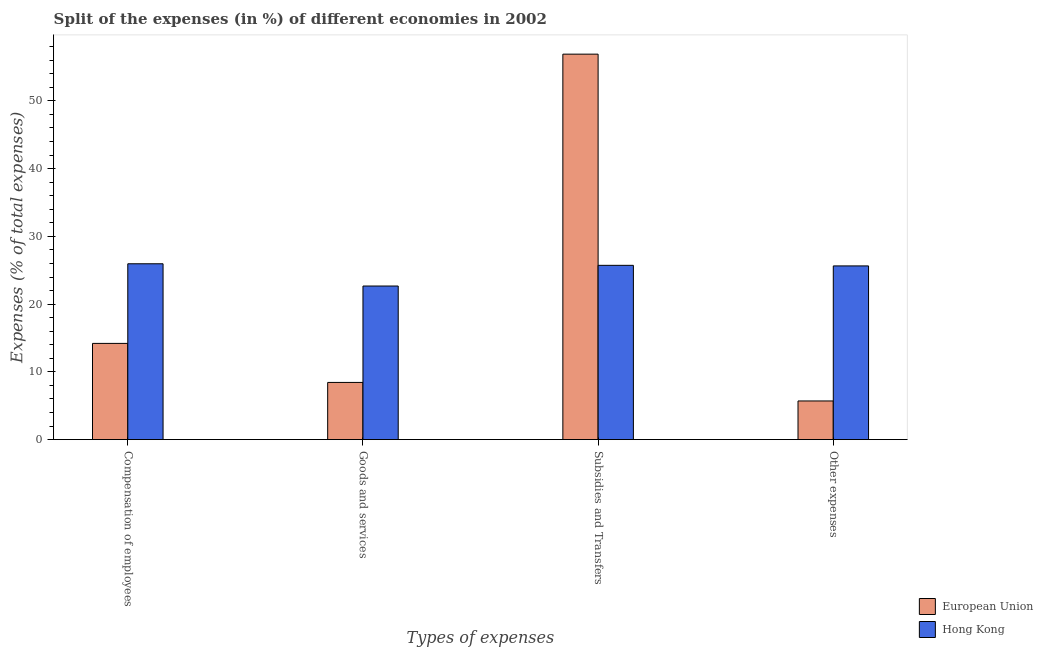Are the number of bars per tick equal to the number of legend labels?
Your response must be concise. Yes. Are the number of bars on each tick of the X-axis equal?
Ensure brevity in your answer.  Yes. How many bars are there on the 1st tick from the left?
Give a very brief answer. 2. How many bars are there on the 3rd tick from the right?
Offer a very short reply. 2. What is the label of the 1st group of bars from the left?
Provide a succinct answer. Compensation of employees. What is the percentage of amount spent on subsidies in Hong Kong?
Give a very brief answer. 25.72. Across all countries, what is the maximum percentage of amount spent on compensation of employees?
Your response must be concise. 25.95. Across all countries, what is the minimum percentage of amount spent on subsidies?
Ensure brevity in your answer.  25.72. In which country was the percentage of amount spent on subsidies maximum?
Offer a terse response. European Union. In which country was the percentage of amount spent on other expenses minimum?
Make the answer very short. European Union. What is the total percentage of amount spent on subsidies in the graph?
Give a very brief answer. 82.62. What is the difference between the percentage of amount spent on subsidies in European Union and that in Hong Kong?
Make the answer very short. 31.17. What is the difference between the percentage of amount spent on goods and services in European Union and the percentage of amount spent on subsidies in Hong Kong?
Your answer should be compact. -17.28. What is the average percentage of amount spent on subsidies per country?
Give a very brief answer. 41.31. What is the difference between the percentage of amount spent on other expenses and percentage of amount spent on compensation of employees in European Union?
Ensure brevity in your answer.  -8.5. In how many countries, is the percentage of amount spent on subsidies greater than 16 %?
Your answer should be very brief. 2. What is the ratio of the percentage of amount spent on goods and services in European Union to that in Hong Kong?
Your answer should be very brief. 0.37. Is the percentage of amount spent on compensation of employees in European Union less than that in Hong Kong?
Provide a succinct answer. Yes. Is the difference between the percentage of amount spent on compensation of employees in European Union and Hong Kong greater than the difference between the percentage of amount spent on other expenses in European Union and Hong Kong?
Ensure brevity in your answer.  Yes. What is the difference between the highest and the second highest percentage of amount spent on subsidies?
Your response must be concise. 31.17. What is the difference between the highest and the lowest percentage of amount spent on subsidies?
Make the answer very short. 31.17. Is it the case that in every country, the sum of the percentage of amount spent on goods and services and percentage of amount spent on compensation of employees is greater than the sum of percentage of amount spent on other expenses and percentage of amount spent on subsidies?
Offer a very short reply. No. What does the 2nd bar from the left in Subsidies and Transfers represents?
Offer a terse response. Hong Kong. Are the values on the major ticks of Y-axis written in scientific E-notation?
Keep it short and to the point. No. Where does the legend appear in the graph?
Your answer should be very brief. Bottom right. What is the title of the graph?
Give a very brief answer. Split of the expenses (in %) of different economies in 2002. What is the label or title of the X-axis?
Ensure brevity in your answer.  Types of expenses. What is the label or title of the Y-axis?
Ensure brevity in your answer.  Expenses (% of total expenses). What is the Expenses (% of total expenses) of European Union in Compensation of employees?
Your answer should be compact. 14.2. What is the Expenses (% of total expenses) of Hong Kong in Compensation of employees?
Your answer should be very brief. 25.95. What is the Expenses (% of total expenses) of European Union in Goods and services?
Keep it short and to the point. 8.44. What is the Expenses (% of total expenses) in Hong Kong in Goods and services?
Offer a very short reply. 22.67. What is the Expenses (% of total expenses) of European Union in Subsidies and Transfers?
Give a very brief answer. 56.89. What is the Expenses (% of total expenses) of Hong Kong in Subsidies and Transfers?
Your answer should be very brief. 25.72. What is the Expenses (% of total expenses) in European Union in Other expenses?
Your response must be concise. 5.7. What is the Expenses (% of total expenses) of Hong Kong in Other expenses?
Offer a terse response. 25.64. Across all Types of expenses, what is the maximum Expenses (% of total expenses) in European Union?
Your response must be concise. 56.89. Across all Types of expenses, what is the maximum Expenses (% of total expenses) of Hong Kong?
Your answer should be very brief. 25.95. Across all Types of expenses, what is the minimum Expenses (% of total expenses) in European Union?
Make the answer very short. 5.7. Across all Types of expenses, what is the minimum Expenses (% of total expenses) in Hong Kong?
Offer a terse response. 22.67. What is the total Expenses (% of total expenses) of European Union in the graph?
Provide a succinct answer. 85.24. What is the total Expenses (% of total expenses) in Hong Kong in the graph?
Give a very brief answer. 99.98. What is the difference between the Expenses (% of total expenses) of European Union in Compensation of employees and that in Goods and services?
Your response must be concise. 5.76. What is the difference between the Expenses (% of total expenses) in Hong Kong in Compensation of employees and that in Goods and services?
Make the answer very short. 3.29. What is the difference between the Expenses (% of total expenses) in European Union in Compensation of employees and that in Subsidies and Transfers?
Your answer should be very brief. -42.69. What is the difference between the Expenses (% of total expenses) in Hong Kong in Compensation of employees and that in Subsidies and Transfers?
Keep it short and to the point. 0.23. What is the difference between the Expenses (% of total expenses) in European Union in Compensation of employees and that in Other expenses?
Your response must be concise. 8.5. What is the difference between the Expenses (% of total expenses) in Hong Kong in Compensation of employees and that in Other expenses?
Keep it short and to the point. 0.32. What is the difference between the Expenses (% of total expenses) of European Union in Goods and services and that in Subsidies and Transfers?
Give a very brief answer. -48.46. What is the difference between the Expenses (% of total expenses) in Hong Kong in Goods and services and that in Subsidies and Transfers?
Ensure brevity in your answer.  -3.06. What is the difference between the Expenses (% of total expenses) of European Union in Goods and services and that in Other expenses?
Offer a very short reply. 2.73. What is the difference between the Expenses (% of total expenses) of Hong Kong in Goods and services and that in Other expenses?
Make the answer very short. -2.97. What is the difference between the Expenses (% of total expenses) of European Union in Subsidies and Transfers and that in Other expenses?
Give a very brief answer. 51.19. What is the difference between the Expenses (% of total expenses) in Hong Kong in Subsidies and Transfers and that in Other expenses?
Make the answer very short. 0.09. What is the difference between the Expenses (% of total expenses) in European Union in Compensation of employees and the Expenses (% of total expenses) in Hong Kong in Goods and services?
Your answer should be very brief. -8.47. What is the difference between the Expenses (% of total expenses) of European Union in Compensation of employees and the Expenses (% of total expenses) of Hong Kong in Subsidies and Transfers?
Your response must be concise. -11.52. What is the difference between the Expenses (% of total expenses) in European Union in Compensation of employees and the Expenses (% of total expenses) in Hong Kong in Other expenses?
Your answer should be very brief. -11.44. What is the difference between the Expenses (% of total expenses) in European Union in Goods and services and the Expenses (% of total expenses) in Hong Kong in Subsidies and Transfers?
Your response must be concise. -17.28. What is the difference between the Expenses (% of total expenses) in European Union in Goods and services and the Expenses (% of total expenses) in Hong Kong in Other expenses?
Your response must be concise. -17.2. What is the difference between the Expenses (% of total expenses) in European Union in Subsidies and Transfers and the Expenses (% of total expenses) in Hong Kong in Other expenses?
Make the answer very short. 31.26. What is the average Expenses (% of total expenses) in European Union per Types of expenses?
Offer a very short reply. 21.31. What is the average Expenses (% of total expenses) in Hong Kong per Types of expenses?
Your answer should be very brief. 25. What is the difference between the Expenses (% of total expenses) in European Union and Expenses (% of total expenses) in Hong Kong in Compensation of employees?
Provide a succinct answer. -11.75. What is the difference between the Expenses (% of total expenses) in European Union and Expenses (% of total expenses) in Hong Kong in Goods and services?
Provide a succinct answer. -14.23. What is the difference between the Expenses (% of total expenses) in European Union and Expenses (% of total expenses) in Hong Kong in Subsidies and Transfers?
Make the answer very short. 31.17. What is the difference between the Expenses (% of total expenses) in European Union and Expenses (% of total expenses) in Hong Kong in Other expenses?
Ensure brevity in your answer.  -19.93. What is the ratio of the Expenses (% of total expenses) in European Union in Compensation of employees to that in Goods and services?
Provide a short and direct response. 1.68. What is the ratio of the Expenses (% of total expenses) of Hong Kong in Compensation of employees to that in Goods and services?
Your answer should be compact. 1.14. What is the ratio of the Expenses (% of total expenses) in European Union in Compensation of employees to that in Subsidies and Transfers?
Your answer should be very brief. 0.25. What is the ratio of the Expenses (% of total expenses) in Hong Kong in Compensation of employees to that in Subsidies and Transfers?
Keep it short and to the point. 1.01. What is the ratio of the Expenses (% of total expenses) in European Union in Compensation of employees to that in Other expenses?
Your answer should be very brief. 2.49. What is the ratio of the Expenses (% of total expenses) in Hong Kong in Compensation of employees to that in Other expenses?
Your answer should be compact. 1.01. What is the ratio of the Expenses (% of total expenses) in European Union in Goods and services to that in Subsidies and Transfers?
Make the answer very short. 0.15. What is the ratio of the Expenses (% of total expenses) in Hong Kong in Goods and services to that in Subsidies and Transfers?
Make the answer very short. 0.88. What is the ratio of the Expenses (% of total expenses) in European Union in Goods and services to that in Other expenses?
Provide a succinct answer. 1.48. What is the ratio of the Expenses (% of total expenses) of Hong Kong in Goods and services to that in Other expenses?
Offer a very short reply. 0.88. What is the ratio of the Expenses (% of total expenses) in European Union in Subsidies and Transfers to that in Other expenses?
Give a very brief answer. 9.97. What is the difference between the highest and the second highest Expenses (% of total expenses) of European Union?
Make the answer very short. 42.69. What is the difference between the highest and the second highest Expenses (% of total expenses) in Hong Kong?
Offer a very short reply. 0.23. What is the difference between the highest and the lowest Expenses (% of total expenses) of European Union?
Your response must be concise. 51.19. What is the difference between the highest and the lowest Expenses (% of total expenses) in Hong Kong?
Keep it short and to the point. 3.29. 